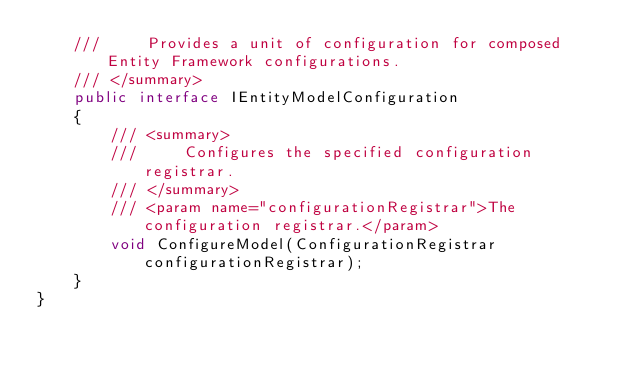Convert code to text. <code><loc_0><loc_0><loc_500><loc_500><_C#_>    ///     Provides a unit of configuration for composed Entity Framework configurations.
    /// </summary>
    public interface IEntityModelConfiguration
    {
        /// <summary>
        ///     Configures the specified configuration registrar.
        /// </summary>
        /// <param name="configurationRegistrar">The configuration registrar.</param>
        void ConfigureModel(ConfigurationRegistrar configurationRegistrar);
    }
}
</code> 